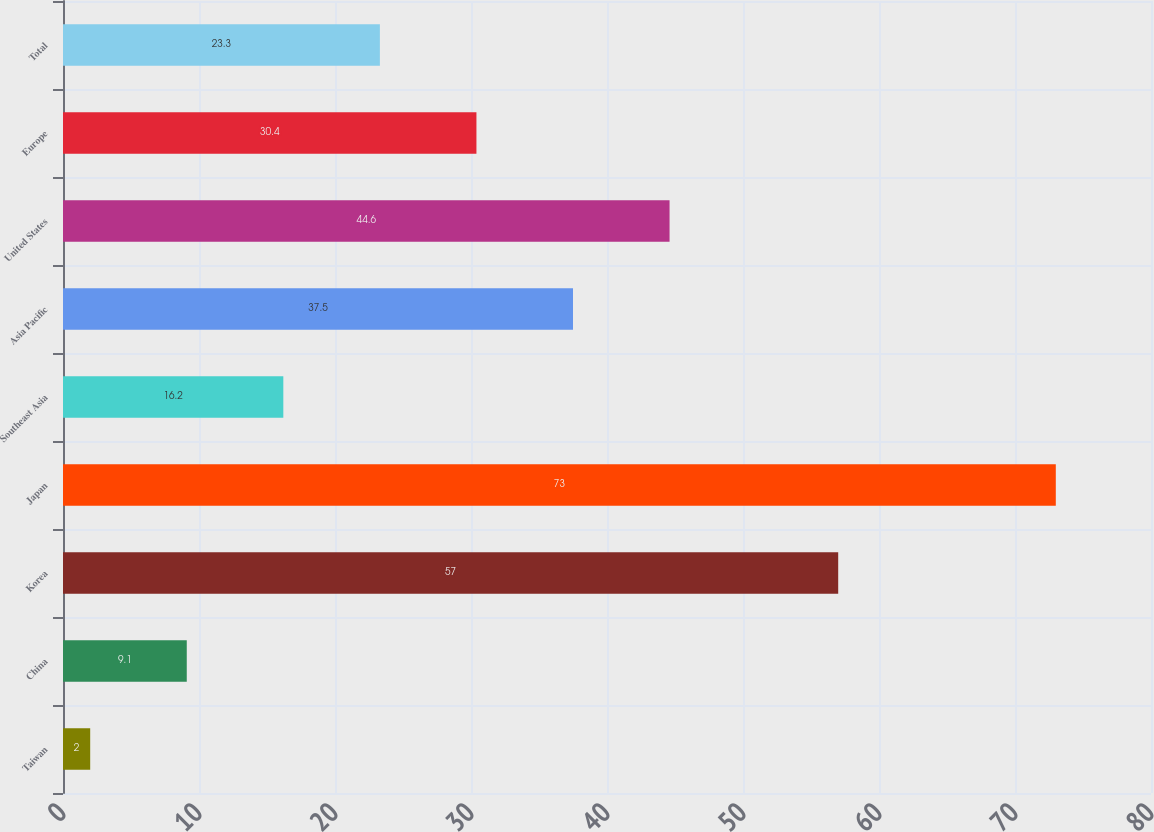<chart> <loc_0><loc_0><loc_500><loc_500><bar_chart><fcel>Taiwan<fcel>China<fcel>Korea<fcel>Japan<fcel>Southeast Asia<fcel>Asia Pacific<fcel>United States<fcel>Europe<fcel>Total<nl><fcel>2<fcel>9.1<fcel>57<fcel>73<fcel>16.2<fcel>37.5<fcel>44.6<fcel>30.4<fcel>23.3<nl></chart> 